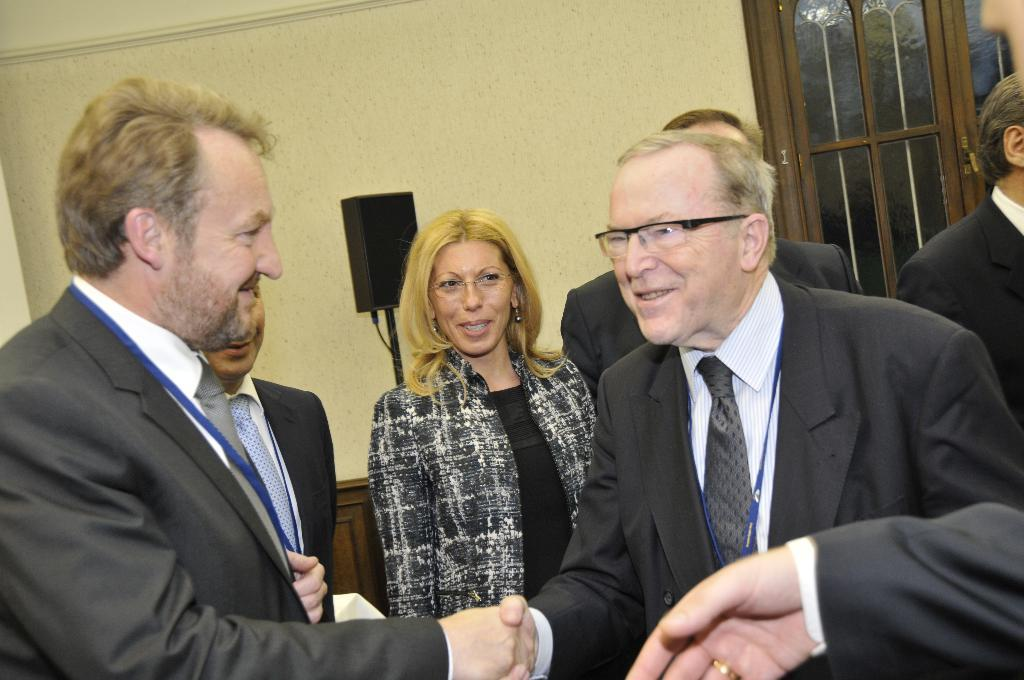What are the people in the image wearing? There are many persons wearing black suits in the image. Can you describe the woman in the image? There is a woman in the middle of the image. What can be seen in the background of the image? There is a wall and a window in the background of the image. What type of fowl can be seen flying through the window in the image? There is no fowl visible in the image, and no fowl is flying through the window. 